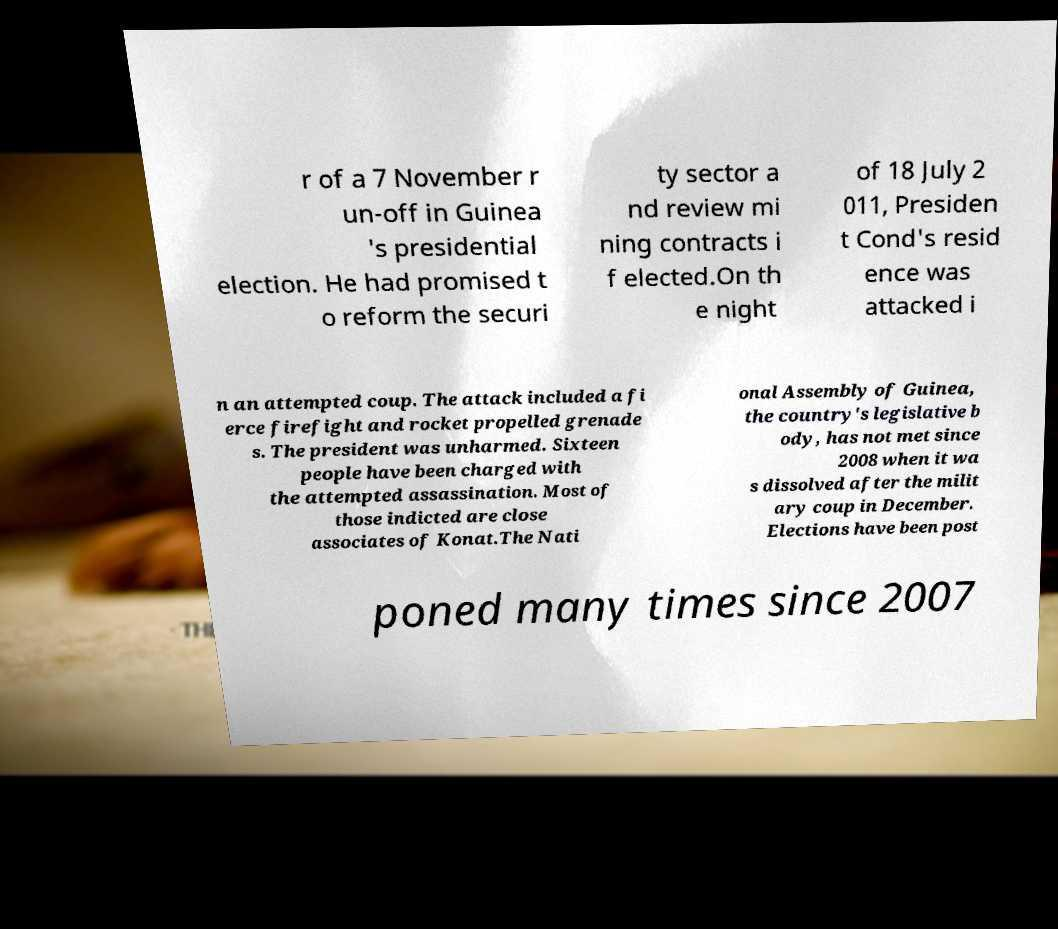I need the written content from this picture converted into text. Can you do that? r of a 7 November r un-off in Guinea 's presidential election. He had promised t o reform the securi ty sector a nd review mi ning contracts i f elected.On th e night of 18 July 2 011, Presiden t Cond's resid ence was attacked i n an attempted coup. The attack included a fi erce firefight and rocket propelled grenade s. The president was unharmed. Sixteen people have been charged with the attempted assassination. Most of those indicted are close associates of Konat.The Nati onal Assembly of Guinea, the country's legislative b ody, has not met since 2008 when it wa s dissolved after the milit ary coup in December. Elections have been post poned many times since 2007 